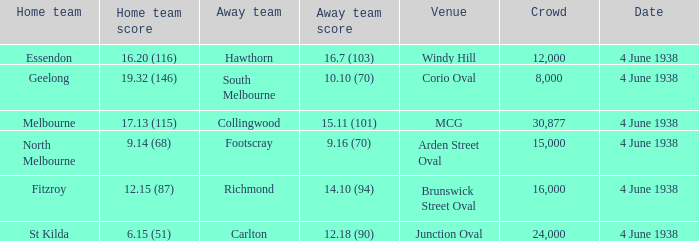How many attended the game at Arden Street Oval? 15000.0. 